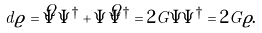Convert formula to latex. <formula><loc_0><loc_0><loc_500><loc_500>d \varrho = \dot { \Psi } \Psi ^ { \dagger } + \Psi \dot { \Psi } ^ { \dagger } = 2 G \Psi \Psi ^ { \dagger } = 2 G \varrho .</formula> 